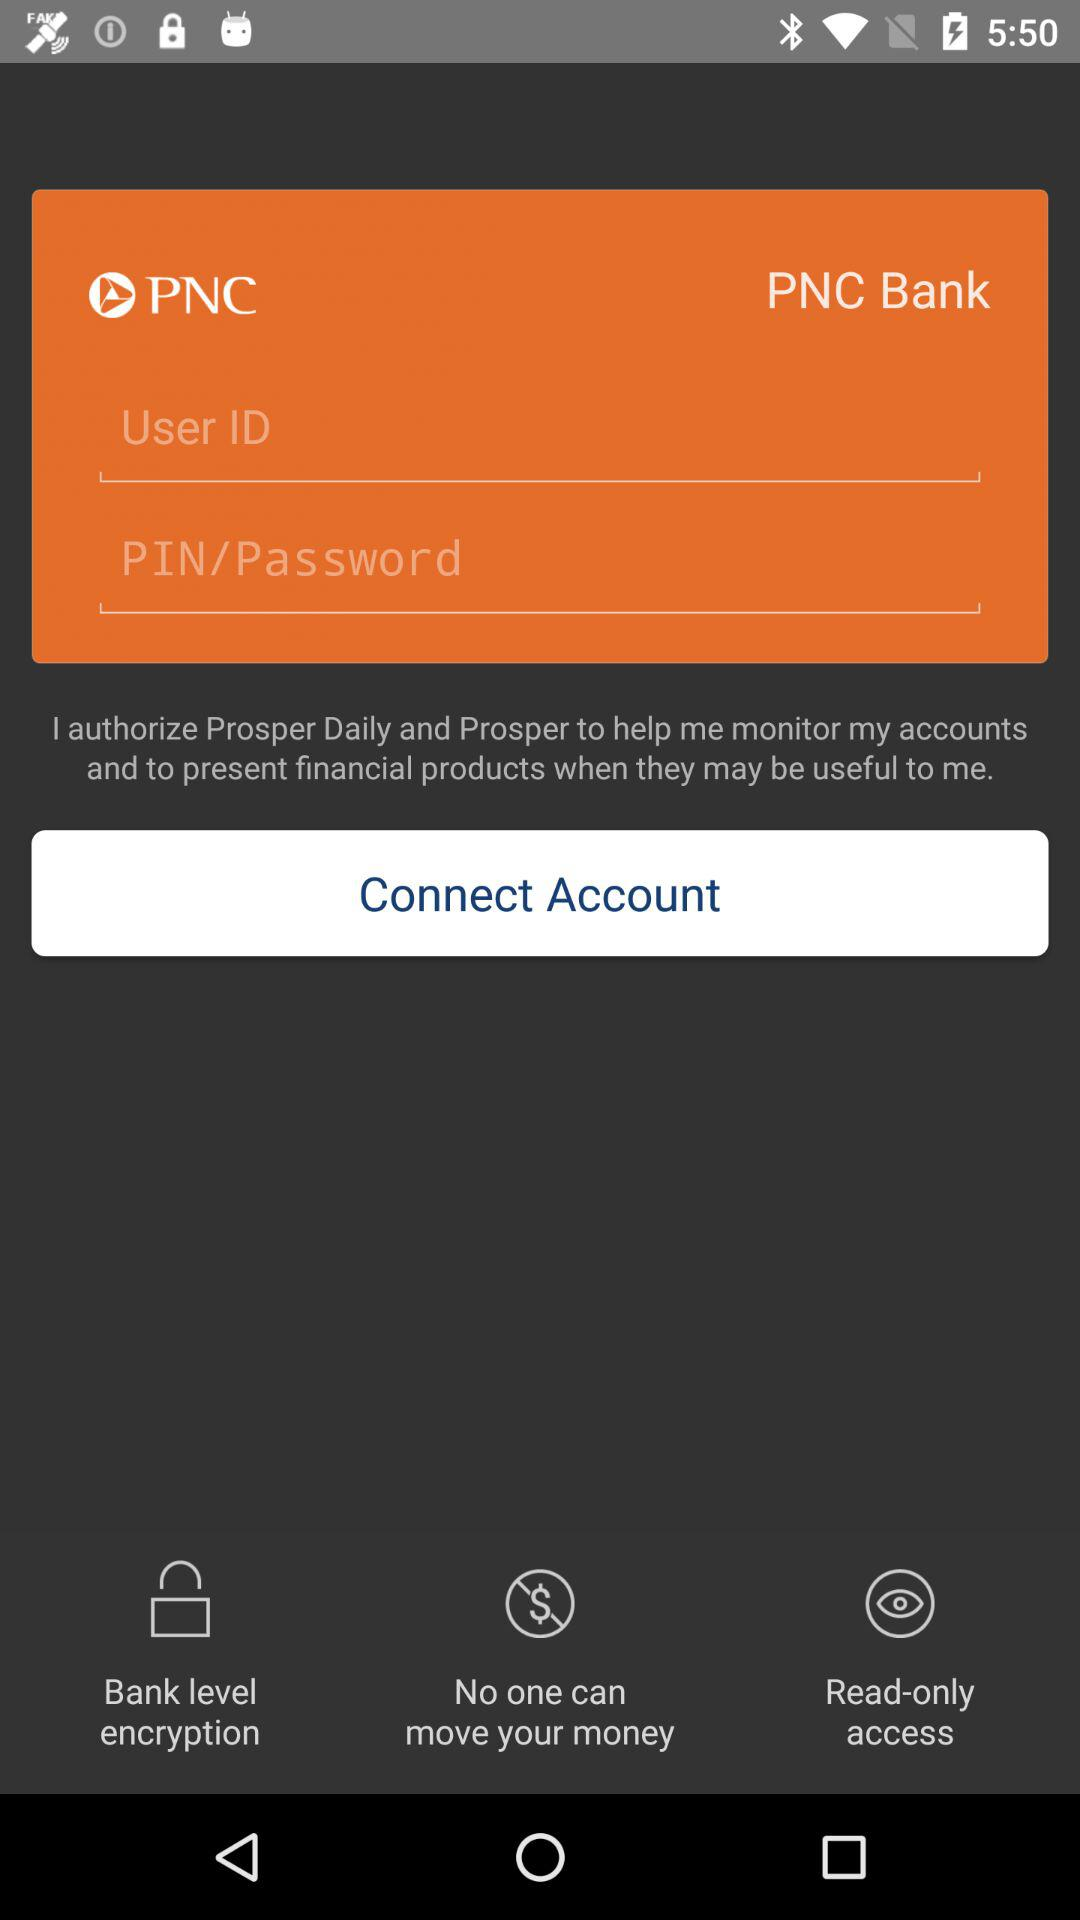What is the name of the bank? The name of the bank is "PNC Bank". 